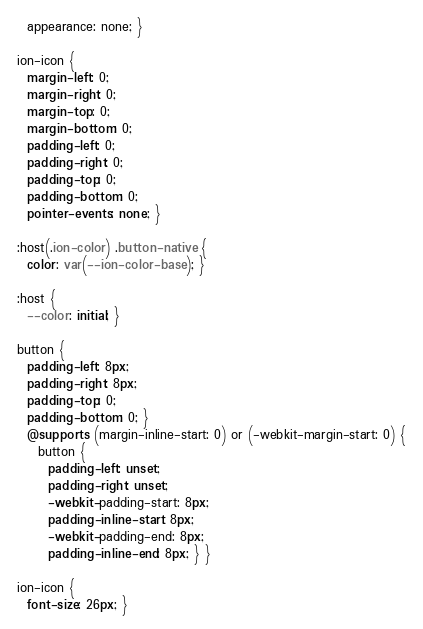<code> <loc_0><loc_0><loc_500><loc_500><_CSS_>  appearance: none; }

ion-icon {
  margin-left: 0;
  margin-right: 0;
  margin-top: 0;
  margin-bottom: 0;
  padding-left: 0;
  padding-right: 0;
  padding-top: 0;
  padding-bottom: 0;
  pointer-events: none; }

:host(.ion-color) .button-native {
  color: var(--ion-color-base); }

:host {
  --color: initial; }

button {
  padding-left: 8px;
  padding-right: 8px;
  padding-top: 0;
  padding-bottom: 0; }
  @supports (margin-inline-start: 0) or (-webkit-margin-start: 0) {
    button {
      padding-left: unset;
      padding-right: unset;
      -webkit-padding-start: 8px;
      padding-inline-start: 8px;
      -webkit-padding-end: 8px;
      padding-inline-end: 8px; } }

ion-icon {
  font-size: 26px; }
</code> 